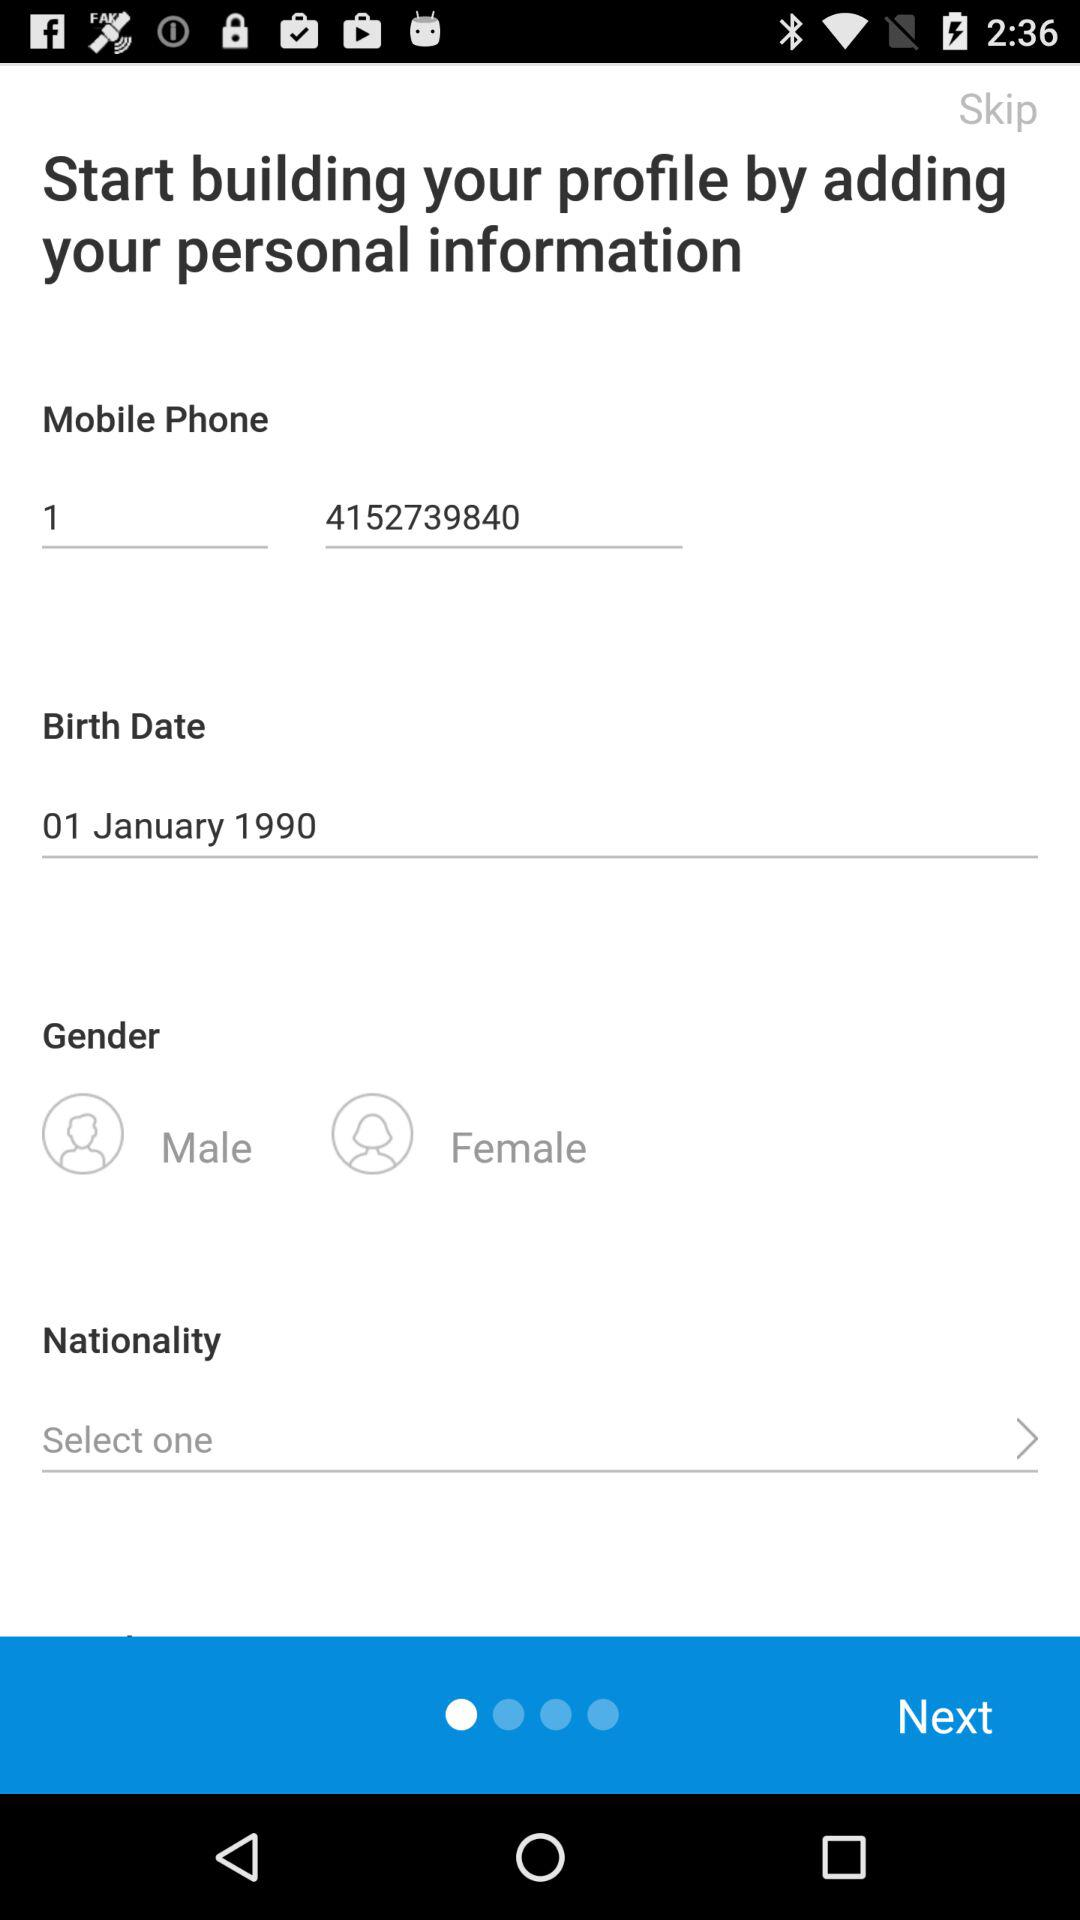How many text inputs are there for the personal information?
Answer the question using a single word or phrase. 3 